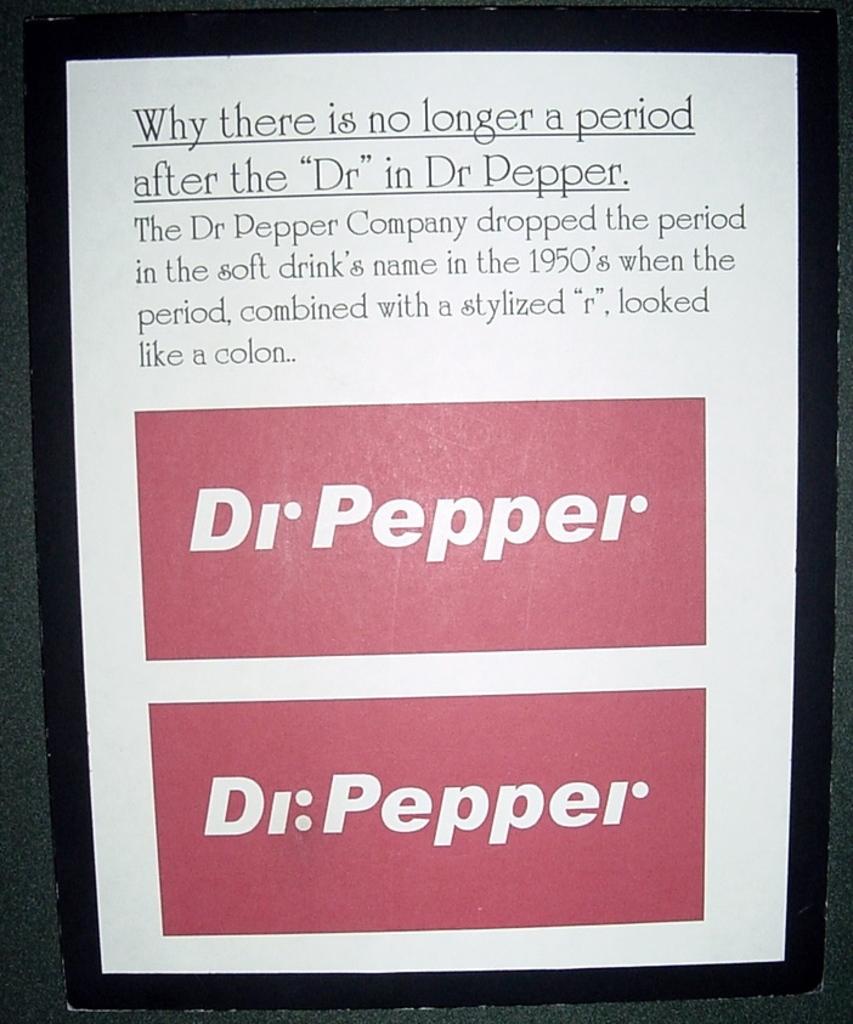What drink is advertised?
Make the answer very short. Dr pepper. 